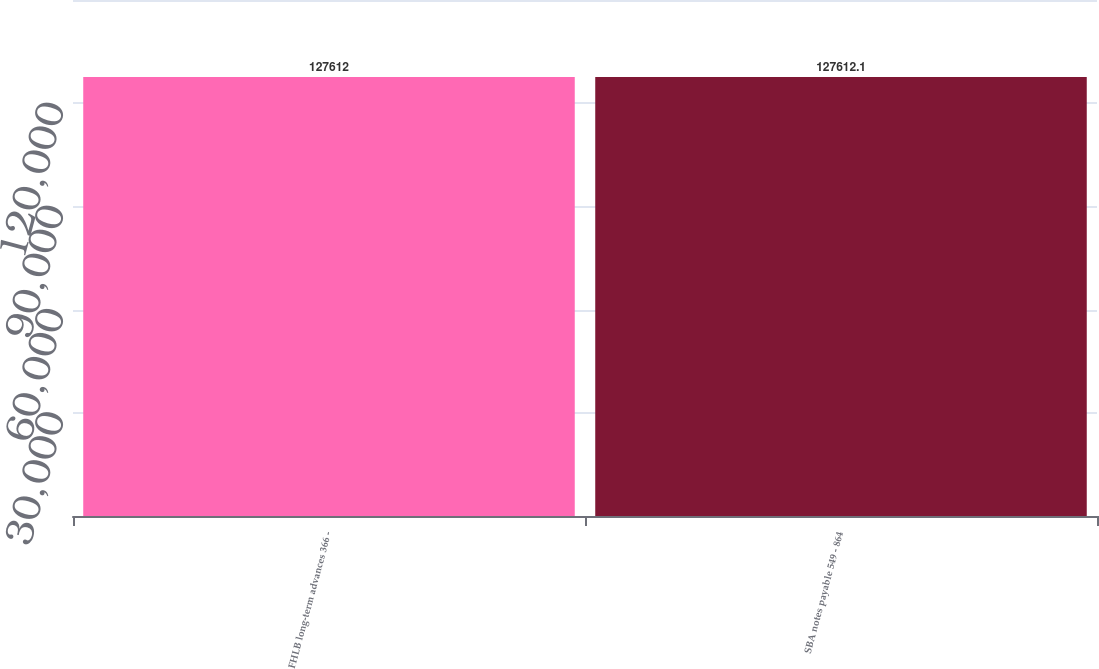Convert chart. <chart><loc_0><loc_0><loc_500><loc_500><bar_chart><fcel>FHLB long-term advances 366 -<fcel>SBA notes payable 549 - 864<nl><fcel>127612<fcel>127612<nl></chart> 